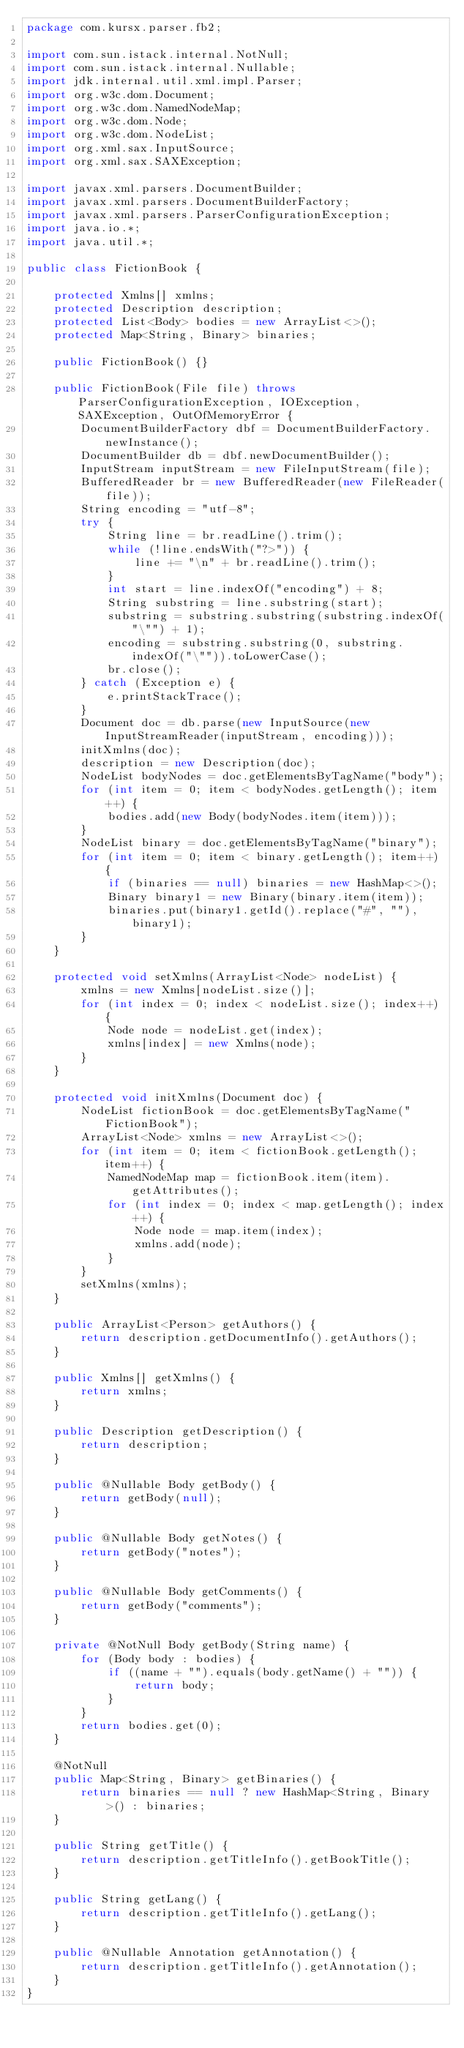<code> <loc_0><loc_0><loc_500><loc_500><_Java_>package com.kursx.parser.fb2;

import com.sun.istack.internal.NotNull;
import com.sun.istack.internal.Nullable;
import jdk.internal.util.xml.impl.Parser;
import org.w3c.dom.Document;
import org.w3c.dom.NamedNodeMap;
import org.w3c.dom.Node;
import org.w3c.dom.NodeList;
import org.xml.sax.InputSource;
import org.xml.sax.SAXException;

import javax.xml.parsers.DocumentBuilder;
import javax.xml.parsers.DocumentBuilderFactory;
import javax.xml.parsers.ParserConfigurationException;
import java.io.*;
import java.util.*;

public class FictionBook {

    protected Xmlns[] xmlns;
    protected Description description;
    protected List<Body> bodies = new ArrayList<>();
    protected Map<String, Binary> binaries;

    public FictionBook() {}

    public FictionBook(File file) throws ParserConfigurationException, IOException, SAXException, OutOfMemoryError {
        DocumentBuilderFactory dbf = DocumentBuilderFactory.newInstance();
        DocumentBuilder db = dbf.newDocumentBuilder();
        InputStream inputStream = new FileInputStream(file);
        BufferedReader br = new BufferedReader(new FileReader(file));
        String encoding = "utf-8";
        try {
            String line = br.readLine().trim();
            while (!line.endsWith("?>")) {
                line += "\n" + br.readLine().trim();
            }
            int start = line.indexOf("encoding") + 8;
            String substring = line.substring(start);
            substring = substring.substring(substring.indexOf("\"") + 1);
            encoding = substring.substring(0, substring.indexOf("\"")).toLowerCase();
            br.close();
        } catch (Exception e) {
            e.printStackTrace();
        }
        Document doc = db.parse(new InputSource(new InputStreamReader(inputStream, encoding)));
        initXmlns(doc);
        description = new Description(doc);
        NodeList bodyNodes = doc.getElementsByTagName("body");
        for (int item = 0; item < bodyNodes.getLength(); item++) {
            bodies.add(new Body(bodyNodes.item(item)));
        }
        NodeList binary = doc.getElementsByTagName("binary");
        for (int item = 0; item < binary.getLength(); item++) {
            if (binaries == null) binaries = new HashMap<>();
            Binary binary1 = new Binary(binary.item(item));
            binaries.put(binary1.getId().replace("#", ""), binary1);
        }
    }

    protected void setXmlns(ArrayList<Node> nodeList) {
        xmlns = new Xmlns[nodeList.size()];
        for (int index = 0; index < nodeList.size(); index++) {
            Node node = nodeList.get(index);
            xmlns[index] = new Xmlns(node);
        }
    }

    protected void initXmlns(Document doc) {
        NodeList fictionBook = doc.getElementsByTagName("FictionBook");
        ArrayList<Node> xmlns = new ArrayList<>();
        for (int item = 0; item < fictionBook.getLength(); item++) {
            NamedNodeMap map = fictionBook.item(item).getAttributes();
            for (int index = 0; index < map.getLength(); index++) {
                Node node = map.item(index);
                xmlns.add(node);
            }
        }
        setXmlns(xmlns);
    }

    public ArrayList<Person> getAuthors() {
        return description.getDocumentInfo().getAuthors();
    }

    public Xmlns[] getXmlns() {
        return xmlns;
    }

    public Description getDescription() {
        return description;
    }

    public @Nullable Body getBody() {
        return getBody(null);
    }

    public @Nullable Body getNotes() {
        return getBody("notes");
    }

    public @Nullable Body getComments() {
        return getBody("comments");
    }

    private @NotNull Body getBody(String name) {
        for (Body body : bodies) {
            if ((name + "").equals(body.getName() + "")) {
                return body;
            }
        }
        return bodies.get(0);
    }

    @NotNull
    public Map<String, Binary> getBinaries() {
        return binaries == null ? new HashMap<String, Binary>() : binaries;
    }

    public String getTitle() {
        return description.getTitleInfo().getBookTitle();
    }

    public String getLang() {
        return description.getTitleInfo().getLang();
    }

    public @Nullable Annotation getAnnotation() {
        return description.getTitleInfo().getAnnotation();
    }
}

</code> 